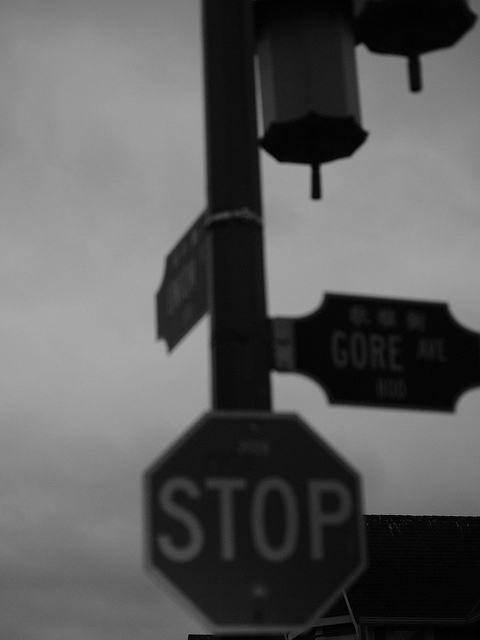Please transcribe the text in this image. STOP GORE 